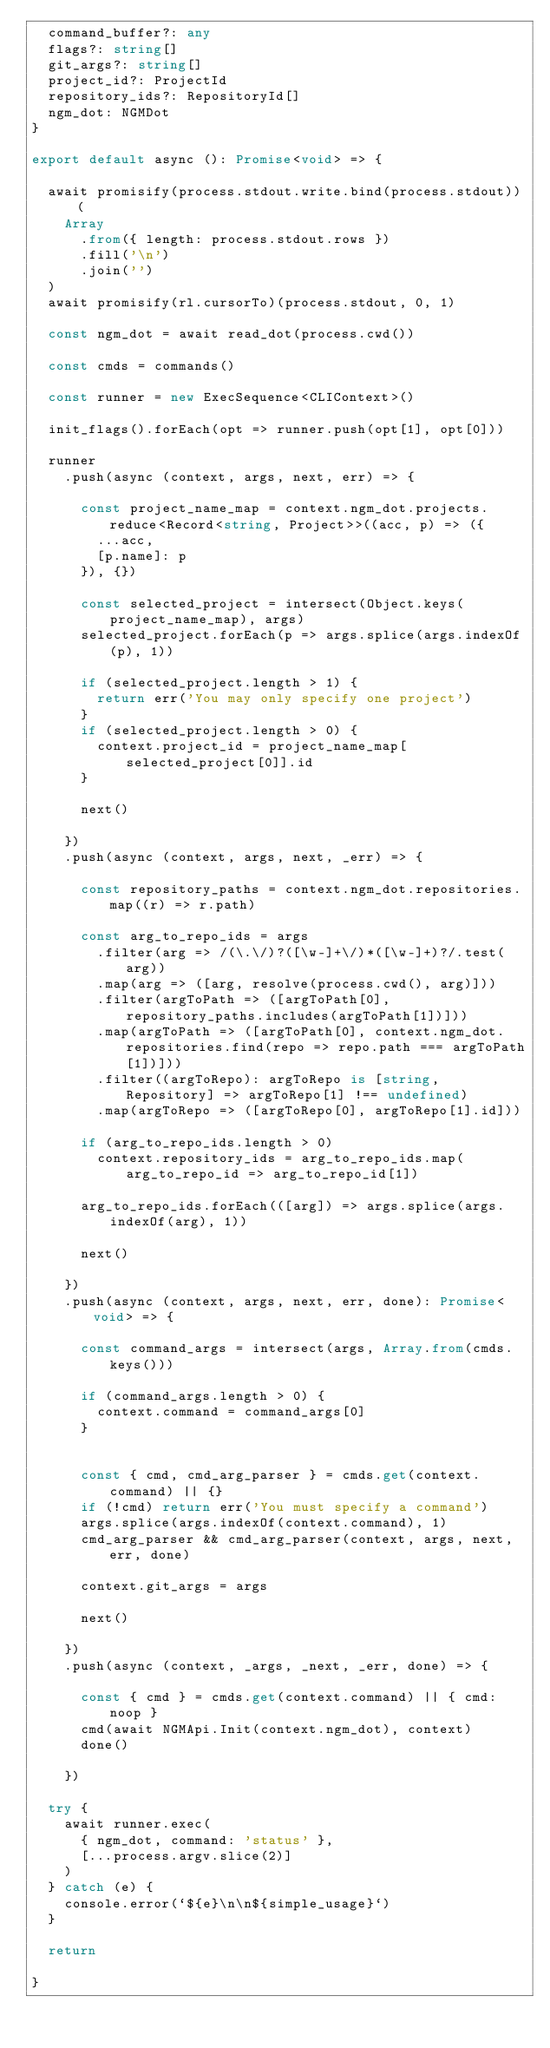Convert code to text. <code><loc_0><loc_0><loc_500><loc_500><_TypeScript_>  command_buffer?: any
  flags?: string[]
  git_args?: string[]
  project_id?: ProjectId
  repository_ids?: RepositoryId[]
  ngm_dot: NGMDot
}

export default async (): Promise<void> => {

  await promisify(process.stdout.write.bind(process.stdout))(
    Array
      .from({ length: process.stdout.rows })
      .fill('\n')
      .join('')
  )
  await promisify(rl.cursorTo)(process.stdout, 0, 1)

  const ngm_dot = await read_dot(process.cwd())

  const cmds = commands()

  const runner = new ExecSequence<CLIContext>()
  
  init_flags().forEach(opt => runner.push(opt[1], opt[0]))

  runner
    .push(async (context, args, next, err) => {

      const project_name_map = context.ngm_dot.projects.reduce<Record<string, Project>>((acc, p) => ({
        ...acc,
        [p.name]: p
      }), {})

      const selected_project = intersect(Object.keys(project_name_map), args)
      selected_project.forEach(p => args.splice(args.indexOf(p), 1))

      if (selected_project.length > 1) {
        return err('You may only specify one project')
      }
      if (selected_project.length > 0) {
        context.project_id = project_name_map[selected_project[0]].id
      }

      next()

    })
    .push(async (context, args, next, _err) => {

      const repository_paths = context.ngm_dot.repositories.map((r) => r.path)

      const arg_to_repo_ids = args
        .filter(arg => /(\.\/)?([\w-]+\/)*([\w-]+)?/.test(arg))
        .map(arg => ([arg, resolve(process.cwd(), arg)]))
        .filter(argToPath => ([argToPath[0], repository_paths.includes(argToPath[1])]))
        .map(argToPath => ([argToPath[0], context.ngm_dot.repositories.find(repo => repo.path === argToPath[1])]))
        .filter((argToRepo): argToRepo is [string, Repository] => argToRepo[1] !== undefined)
        .map(argToRepo => ([argToRepo[0], argToRepo[1].id]))

      if (arg_to_repo_ids.length > 0)
        context.repository_ids = arg_to_repo_ids.map(arg_to_repo_id => arg_to_repo_id[1])
      
      arg_to_repo_ids.forEach(([arg]) => args.splice(args.indexOf(arg), 1))

      next()

    })
    .push(async (context, args, next, err, done): Promise<void> => {

      const command_args = intersect(args, Array.from(cmds.keys()))

      if (command_args.length > 0) {
        context.command = command_args[0]
      }

      
      const { cmd, cmd_arg_parser } = cmds.get(context.command) || {}
      if (!cmd) return err('You must specify a command')
      args.splice(args.indexOf(context.command), 1)
      cmd_arg_parser && cmd_arg_parser(context, args, next, err, done)

      context.git_args = args

      next()

    })
    .push(async (context, _args, _next, _err, done) => {

      const { cmd } = cmds.get(context.command) || { cmd: noop }
      cmd(await NGMApi.Init(context.ngm_dot), context)
      done()

    })

  try {
    await runner.exec(
      { ngm_dot, command: 'status' },
      [...process.argv.slice(2)]
    )
  } catch (e) {
    console.error(`${e}\n\n${simple_usage}`)
  }

  return
  
}
</code> 